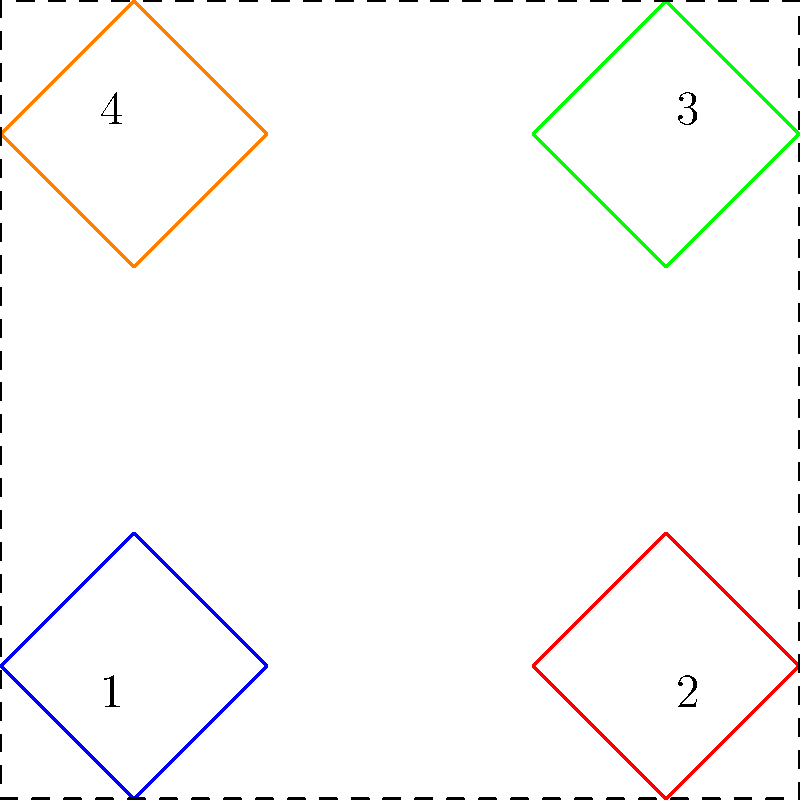A basic SCP containment symbol is represented by a square rotated 45 degrees. Starting from position 1, the symbol undergoes a series of transformations to reach positions 2, 3, and 4. Each transformation involves a 90-degree rotation followed by a translation of 2 units. What is the total rotation angle (in degrees) experienced by the symbol from its initial position in 1 to its final position in 4? Let's break down the transformations step by step:

1. Initial position (1): The symbol starts rotated 45 degrees.

2. From 1 to 2:
   - Rotated 90 degrees clockwise
   - Translated 2 units right
   Total rotation: $45° + 90° = 135°$

3. From 2 to 3:
   - Rotated 90 degrees clockwise
   - Translated 2 units up
   Total rotation: $135° + 90° = 225°$

4. From 3 to 4:
   - Rotated 90 degrees clockwise
   - Translated 2 units left
   Total rotation: $225° + 90° = 315°$

The total rotation angle from the initial position to the final position is:

$315° - 45° = 270°$

This is because we need to subtract the initial 45-degree rotation to find the net rotation experienced by the symbol.
Answer: 270° 